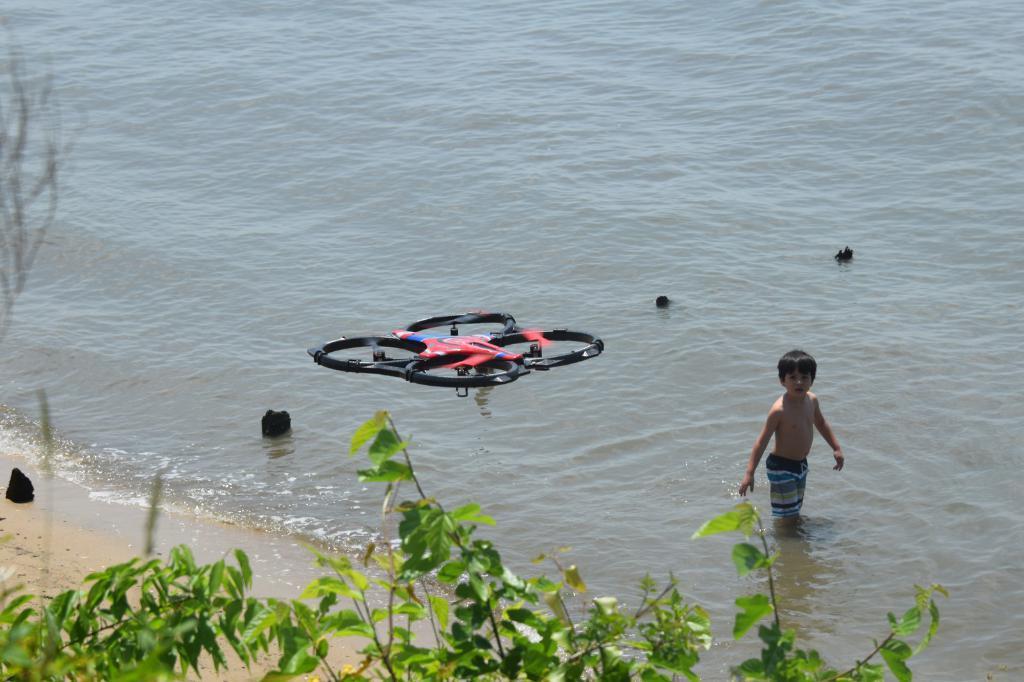Describe this image in one or two sentences. Here we can see few objects on the water and there is a drone here in the air and at the bottom we can see a tree and there is a boy in the water on the right side and there is an object on the sand on the right side. 